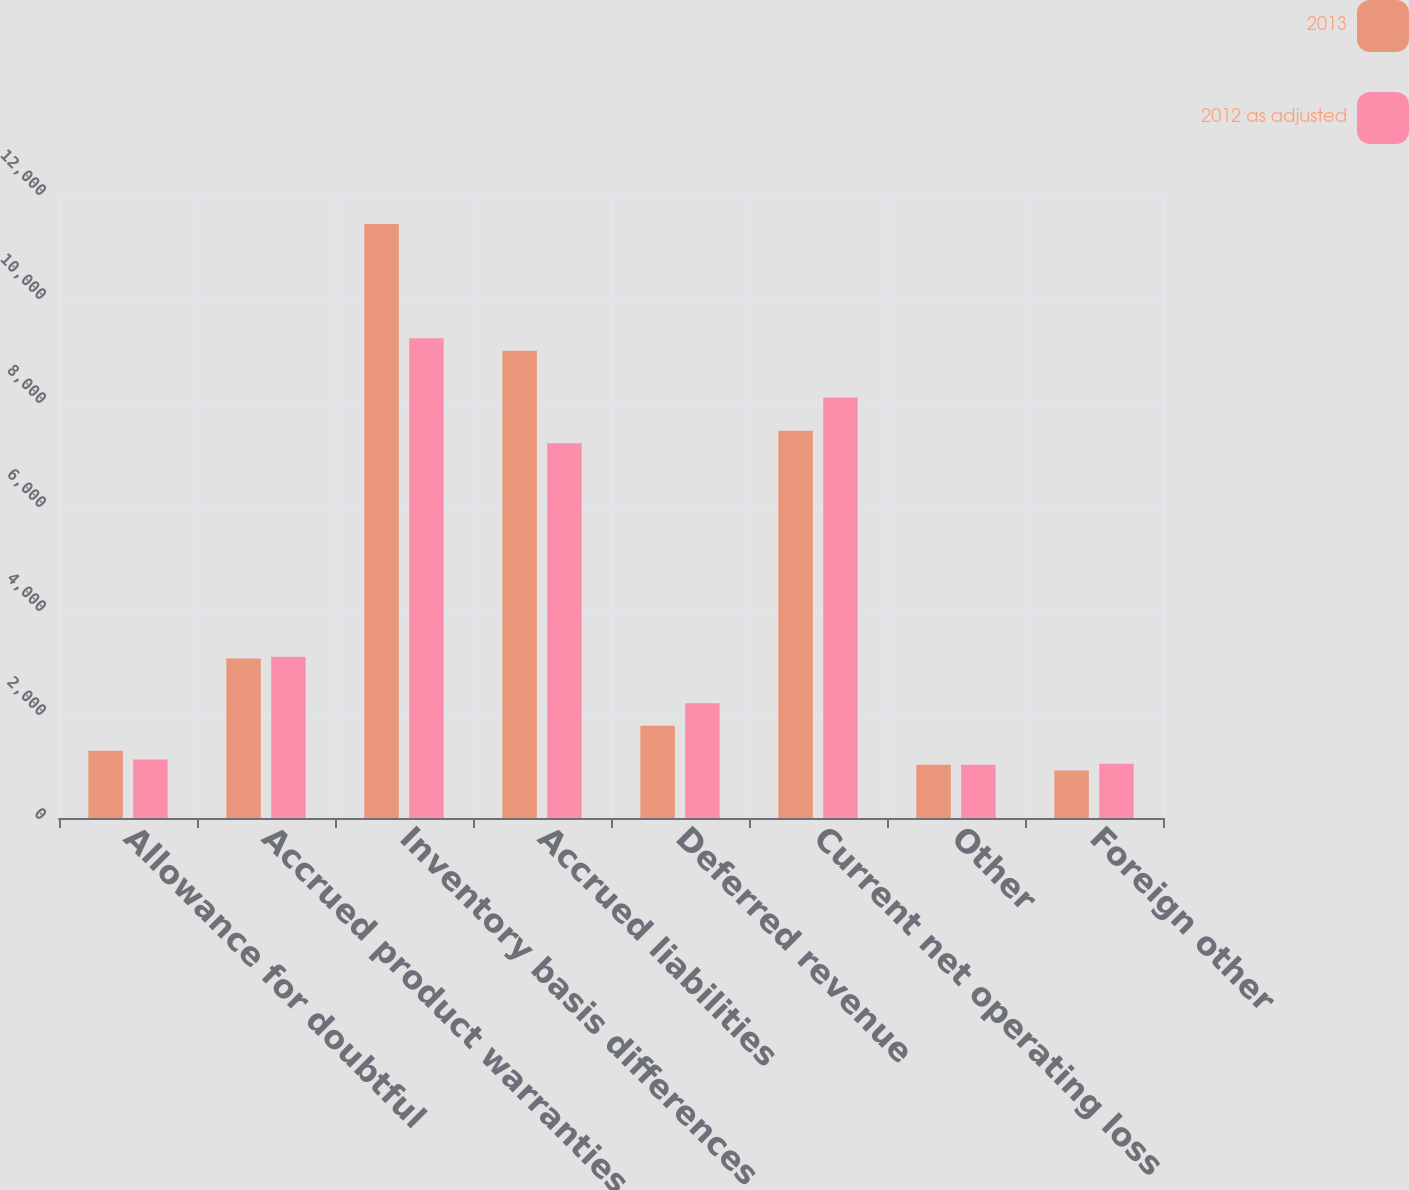<chart> <loc_0><loc_0><loc_500><loc_500><stacked_bar_chart><ecel><fcel>Allowance for doubtful<fcel>Accrued product warranties<fcel>Inventory basis differences<fcel>Accrued liabilities<fcel>Deferred revenue<fcel>Current net operating loss<fcel>Other<fcel>Foreign other<nl><fcel>2013<fcel>1295<fcel>3069<fcel>11421<fcel>8987<fcel>1775<fcel>7449<fcel>1024<fcel>913<nl><fcel>2012 as adjusted<fcel>1123<fcel>3099<fcel>9225<fcel>7206<fcel>2205<fcel>8085<fcel>1025<fcel>1042<nl></chart> 